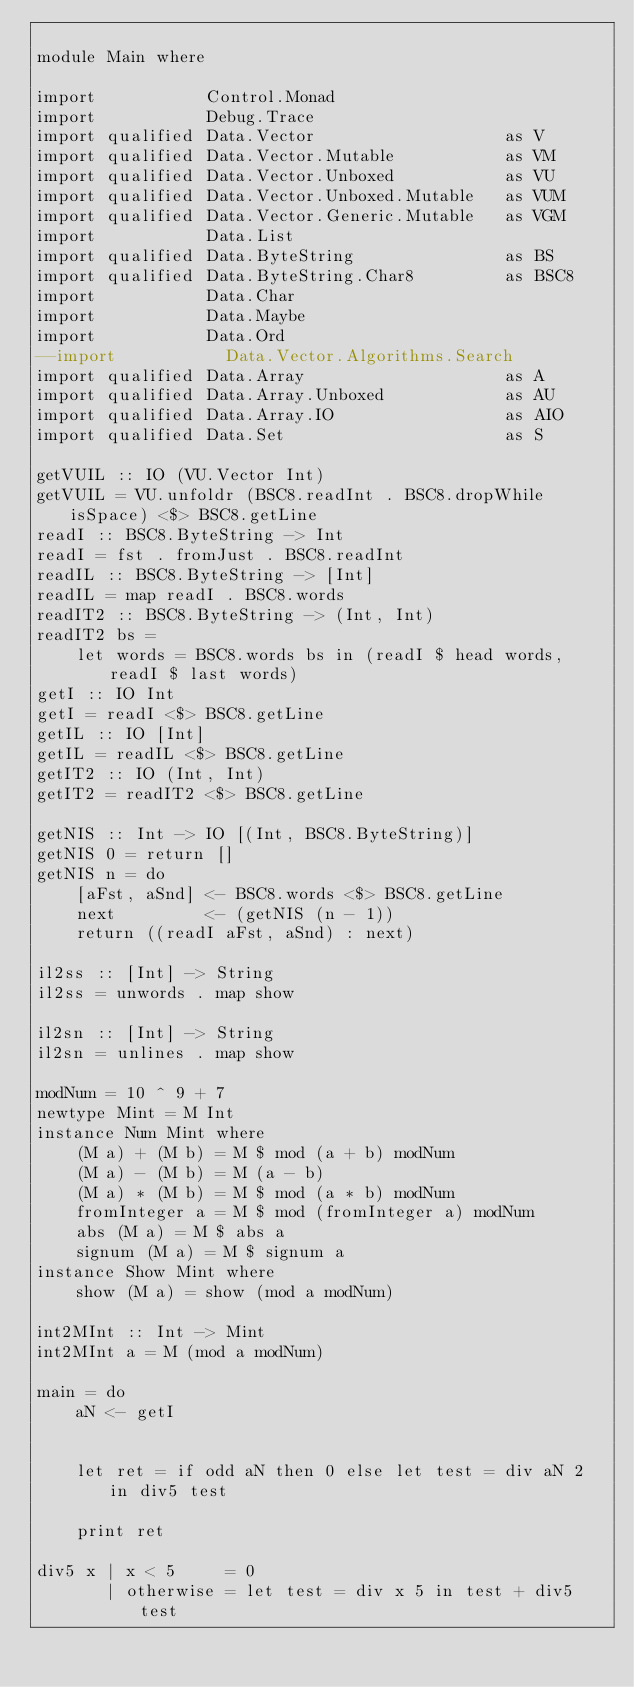Convert code to text. <code><loc_0><loc_0><loc_500><loc_500><_Haskell_>
module Main where

import           Control.Monad
import           Debug.Trace
import qualified Data.Vector                   as V
import qualified Data.Vector.Mutable           as VM
import qualified Data.Vector.Unboxed           as VU
import qualified Data.Vector.Unboxed.Mutable   as VUM
import qualified Data.Vector.Generic.Mutable   as VGM
import           Data.List
import qualified Data.ByteString               as BS
import qualified Data.ByteString.Char8         as BSC8
import           Data.Char
import           Data.Maybe
import           Data.Ord
--import           Data.Vector.Algorithms.Search
import qualified Data.Array                    as A
import qualified Data.Array.Unboxed            as AU
import qualified Data.Array.IO                 as AIO
import qualified Data.Set                      as S

getVUIL :: IO (VU.Vector Int)
getVUIL = VU.unfoldr (BSC8.readInt . BSC8.dropWhile isSpace) <$> BSC8.getLine
readI :: BSC8.ByteString -> Int
readI = fst . fromJust . BSC8.readInt
readIL :: BSC8.ByteString -> [Int]
readIL = map readI . BSC8.words
readIT2 :: BSC8.ByteString -> (Int, Int)
readIT2 bs =
    let words = BSC8.words bs in (readI $ head words, readI $ last words)
getI :: IO Int
getI = readI <$> BSC8.getLine
getIL :: IO [Int]
getIL = readIL <$> BSC8.getLine
getIT2 :: IO (Int, Int)
getIT2 = readIT2 <$> BSC8.getLine

getNIS :: Int -> IO [(Int, BSC8.ByteString)]
getNIS 0 = return []
getNIS n = do
    [aFst, aSnd] <- BSC8.words <$> BSC8.getLine
    next         <- (getNIS (n - 1))
    return ((readI aFst, aSnd) : next)

il2ss :: [Int] -> String
il2ss = unwords . map show

il2sn :: [Int] -> String
il2sn = unlines . map show

modNum = 10 ^ 9 + 7
newtype Mint = M Int
instance Num Mint where
    (M a) + (M b) = M $ mod (a + b) modNum
    (M a) - (M b) = M (a - b)
    (M a) * (M b) = M $ mod (a * b) modNum
    fromInteger a = M $ mod (fromInteger a) modNum
    abs (M a) = M $ abs a
    signum (M a) = M $ signum a
instance Show Mint where
    show (M a) = show (mod a modNum)

int2MInt :: Int -> Mint
int2MInt a = M (mod a modNum)

main = do
    aN <- getI


    let ret = if odd aN then 0 else let test = div aN 2 in div5 test

    print ret

div5 x | x < 5     = 0
       | otherwise = let test = div x 5 in test + div5 test
</code> 